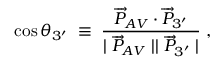Convert formula to latex. <formula><loc_0><loc_0><loc_500><loc_500>\cos \theta _ { 3 ^ { \prime } } \, \equiv \, \frac { \overrightarrow { P } _ { A V } \cdot \overrightarrow { P } _ { 3 ^ { \prime } } } { | \overrightarrow { P } _ { A V } | | \overrightarrow { P } _ { 3 ^ { \prime } } | } \, , \,</formula> 